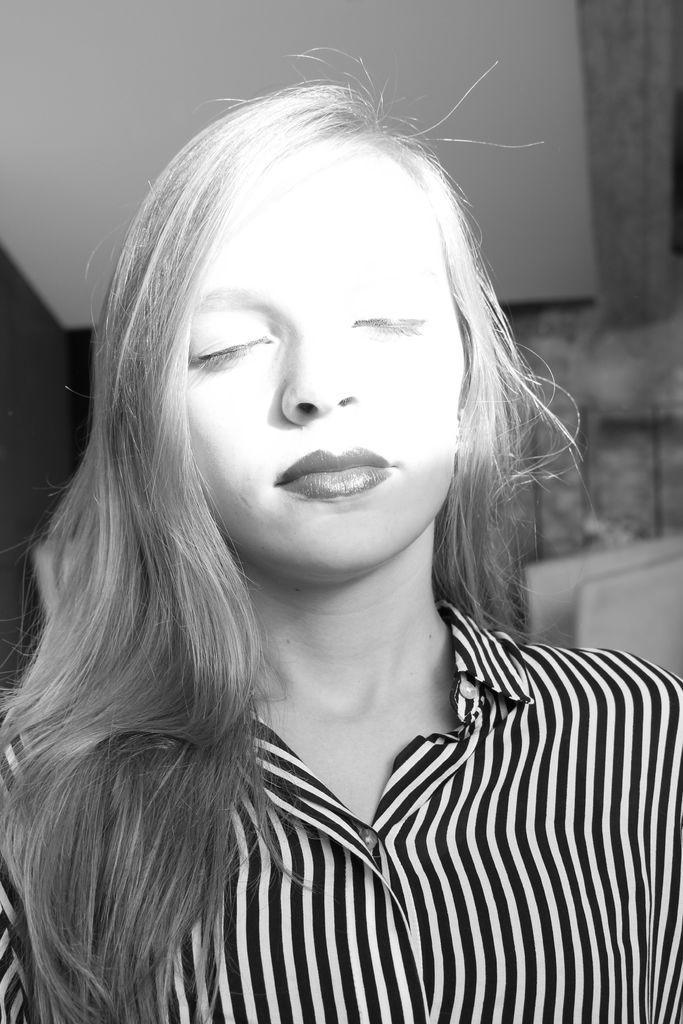In one or two sentences, can you explain what this image depicts? In the center of the image we can see a lady. In the background there is a wall. 